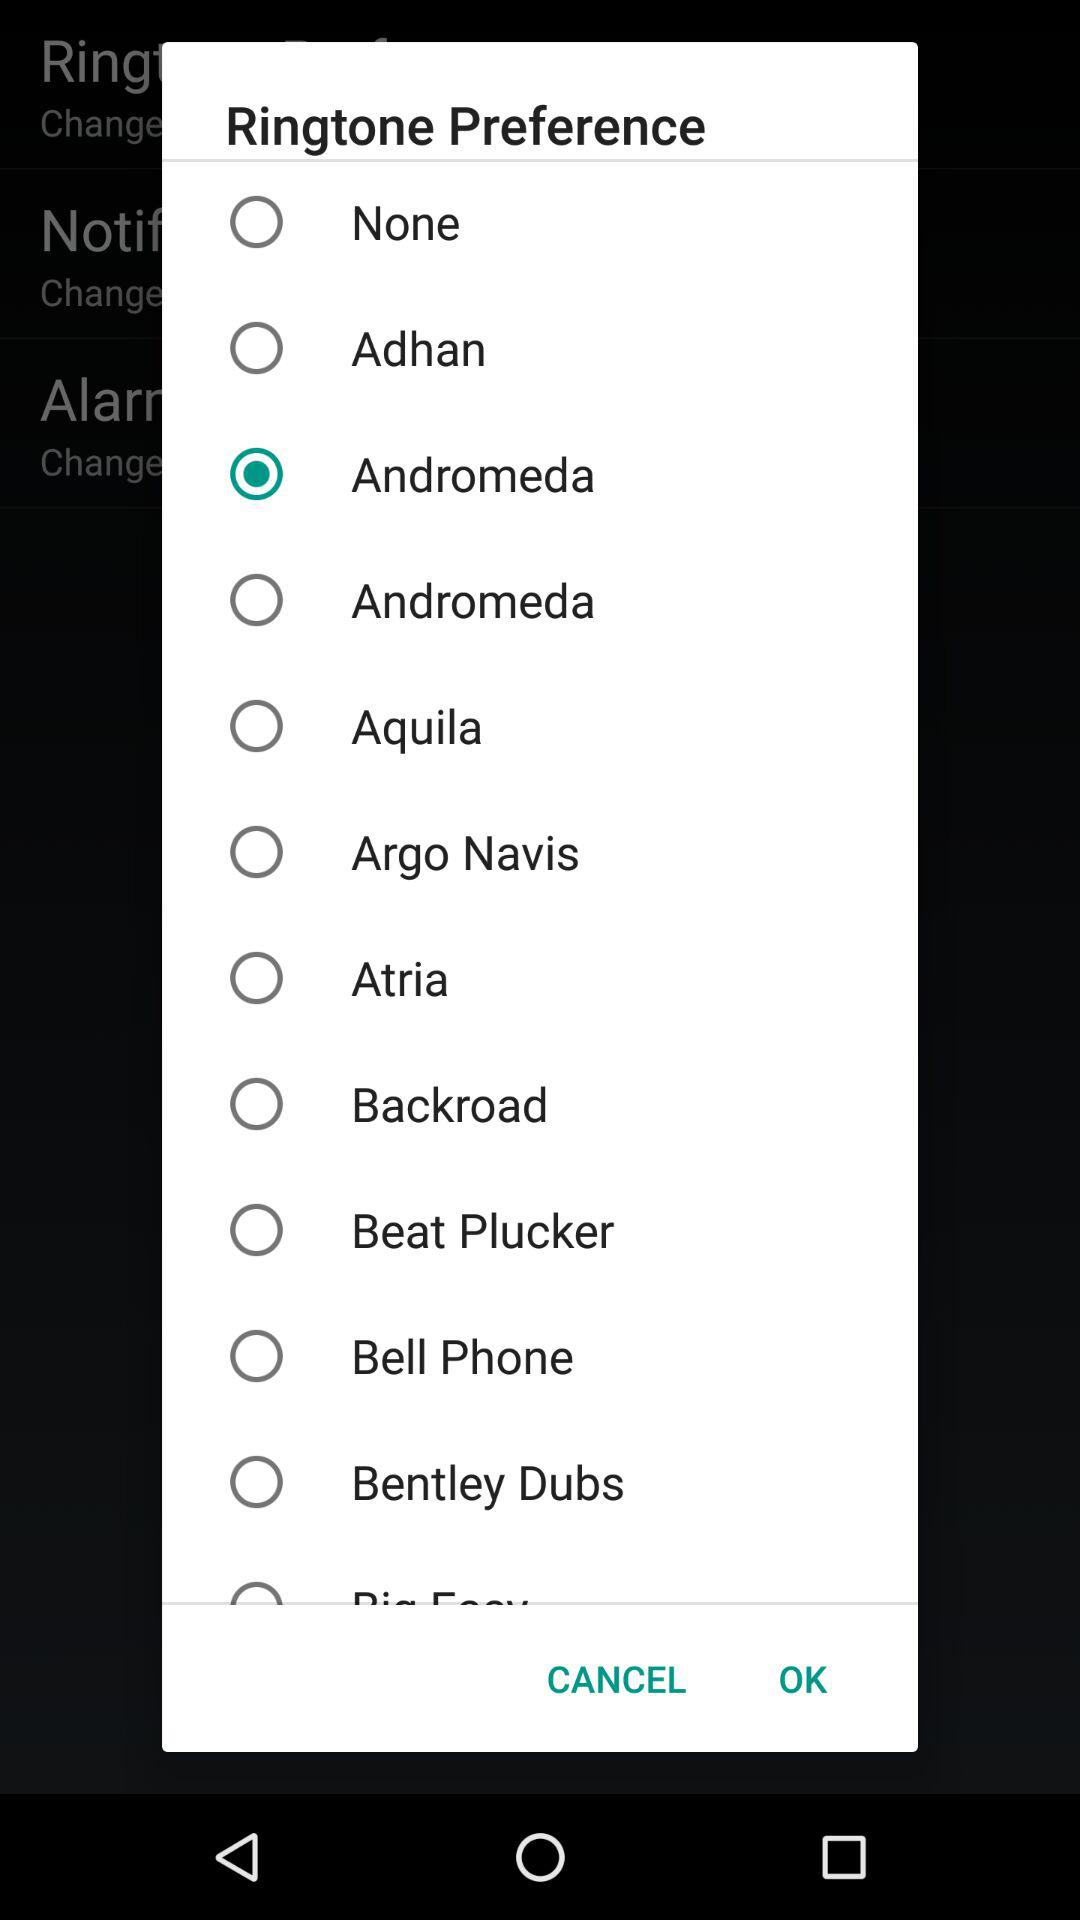Is "Bell Phone" selected or not? "Bell Phone" is not selected. 